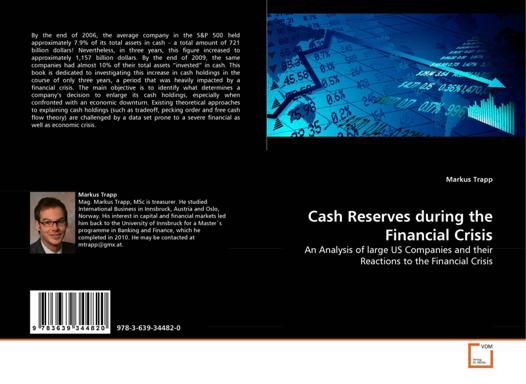What might the significance of the colors on the book cover be? The book cover primarily utilizes blue tones which traditionally symbolize trust, calmness, and stability. These color choices may be intended to reflect the underlying message of the book – navigating through the financial crisis with thoughtful analysis and steady management. 